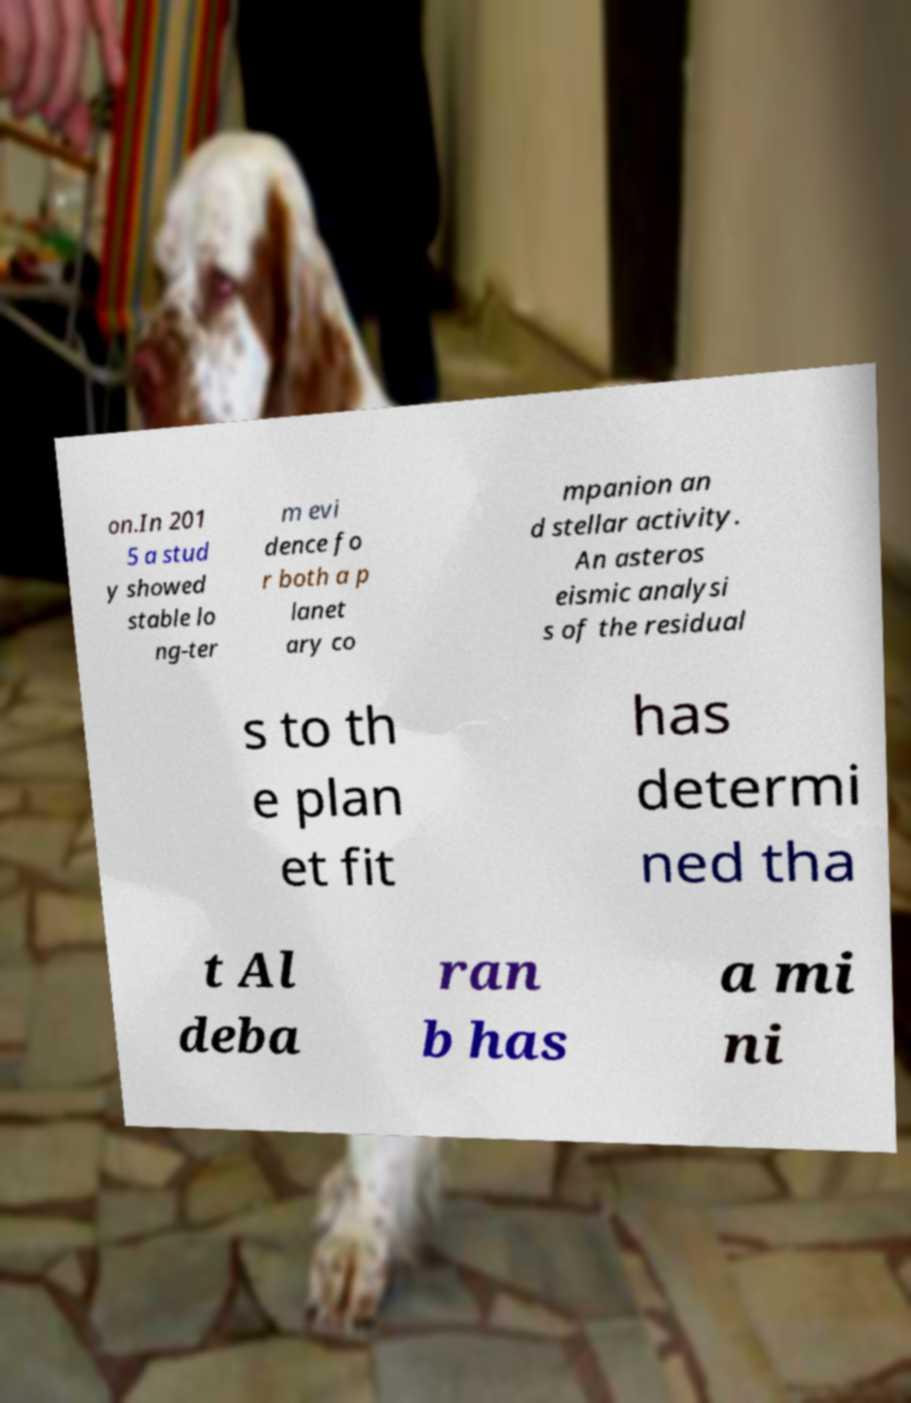There's text embedded in this image that I need extracted. Can you transcribe it verbatim? on.In 201 5 a stud y showed stable lo ng-ter m evi dence fo r both a p lanet ary co mpanion an d stellar activity. An asteros eismic analysi s of the residual s to th e plan et fit has determi ned tha t Al deba ran b has a mi ni 